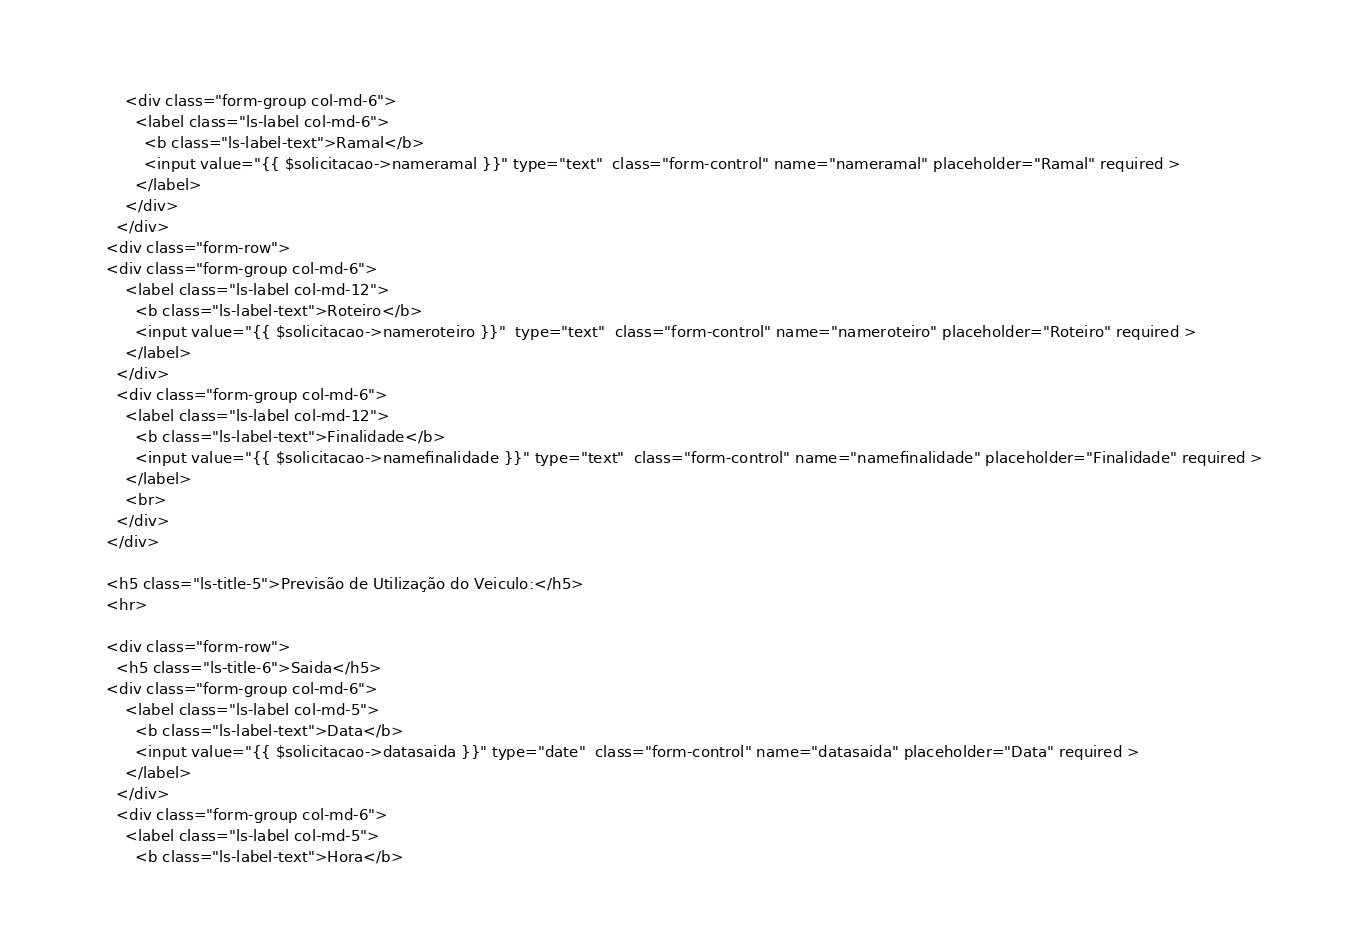Convert code to text. <code><loc_0><loc_0><loc_500><loc_500><_PHP_>        <div class="form-group col-md-6">
          <label class="ls-label col-md-6">
            <b class="ls-label-text">Ramal</b>
            <input value="{{ $solicitacao->nameramal }}" type="text"  class="form-control" name="nameramal" placeholder="Ramal" required >
          </label>
        </div>
      </div>
    <div class="form-row">
    <div class="form-group col-md-6">
        <label class="ls-label col-md-12">
          <b class="ls-label-text">Roteiro</b>
          <input value="{{ $solicitacao->nameroteiro }}"  type="text"  class="form-control" name="nameroteiro" placeholder="Roteiro" required >
        </label>
      </div>
      <div class="form-group col-md-6">
        <label class="ls-label col-md-12">
          <b class="ls-label-text">Finalidade</b>
          <input value="{{ $solicitacao->namefinalidade }}" type="text"  class="form-control" name="namefinalidade" placeholder="Finalidade" required >
        </label>
        <br>
      </div>
    </div>

    <h5 class="ls-title-5">Previsão de Utilização do Veiculo:</h5>
    <hr>

    <div class="form-row">
      <h5 class="ls-title-6">Saida</h5>
    <div class="form-group col-md-6">
        <label class="ls-label col-md-5">
          <b class="ls-label-text">Data</b>
          <input value="{{ $solicitacao->datasaida }}" type="date"  class="form-control" name="datasaida" placeholder="Data" required >
        </label>
      </div>
      <div class="form-group col-md-6">
        <label class="ls-label col-md-5">
          <b class="ls-label-text">Hora</b></code> 